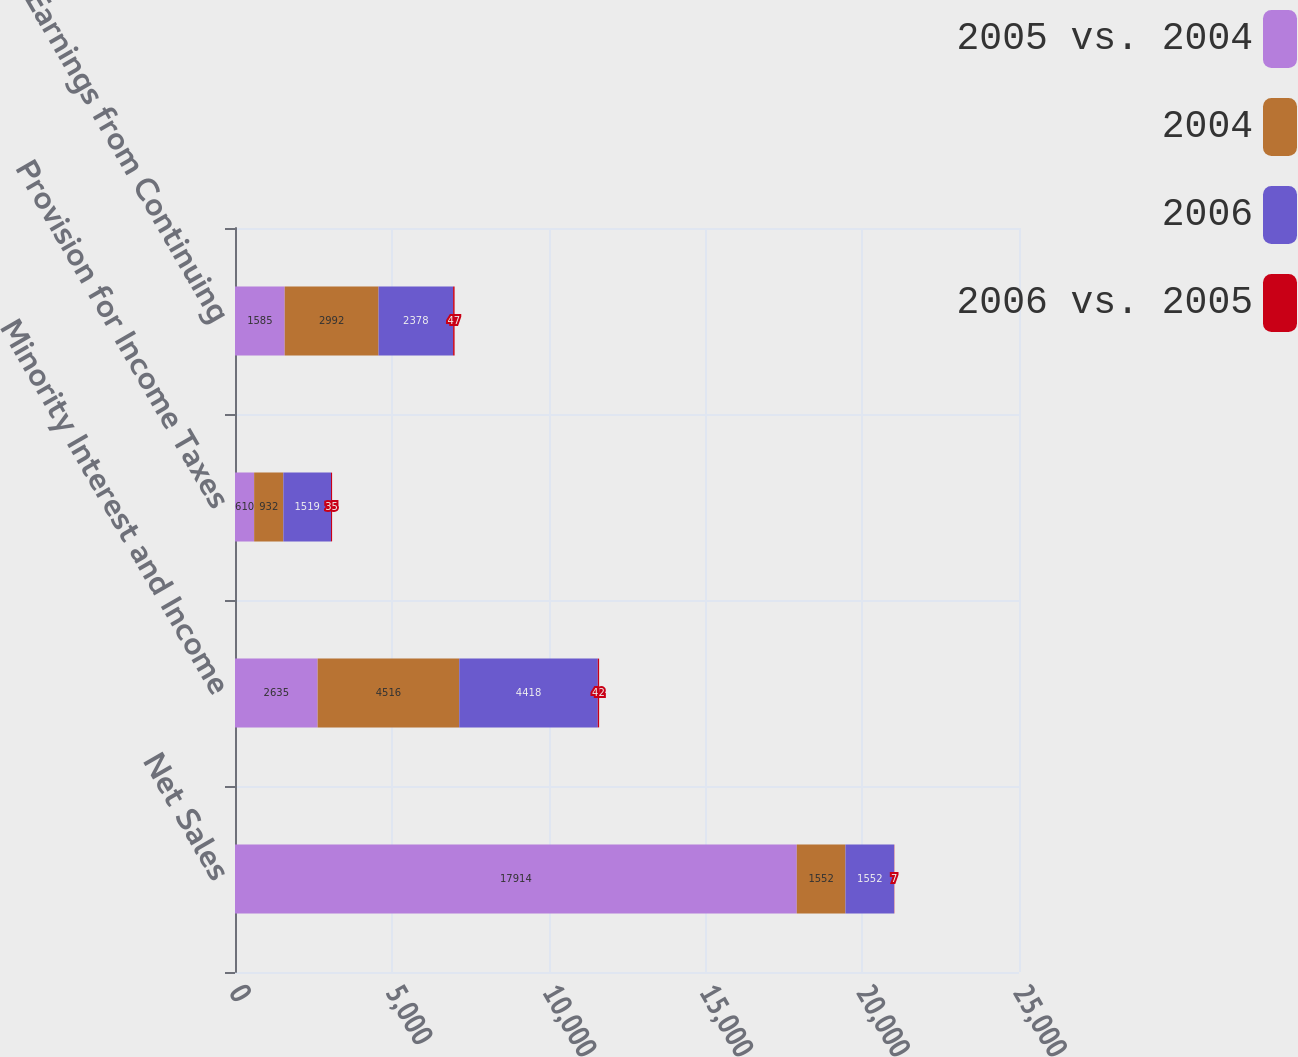<chart> <loc_0><loc_0><loc_500><loc_500><stacked_bar_chart><ecel><fcel>Net Sales<fcel>Minority Interest and Income<fcel>Provision for Income Taxes<fcel>Earnings from Continuing<nl><fcel>2005 vs. 2004<fcel>17914<fcel>2635<fcel>610<fcel>1585<nl><fcel>2004<fcel>1552<fcel>4516<fcel>932<fcel>2992<nl><fcel>2006<fcel>1552<fcel>4418<fcel>1519<fcel>2378<nl><fcel>2006 vs. 2005<fcel>7<fcel>42<fcel>35<fcel>47<nl></chart> 